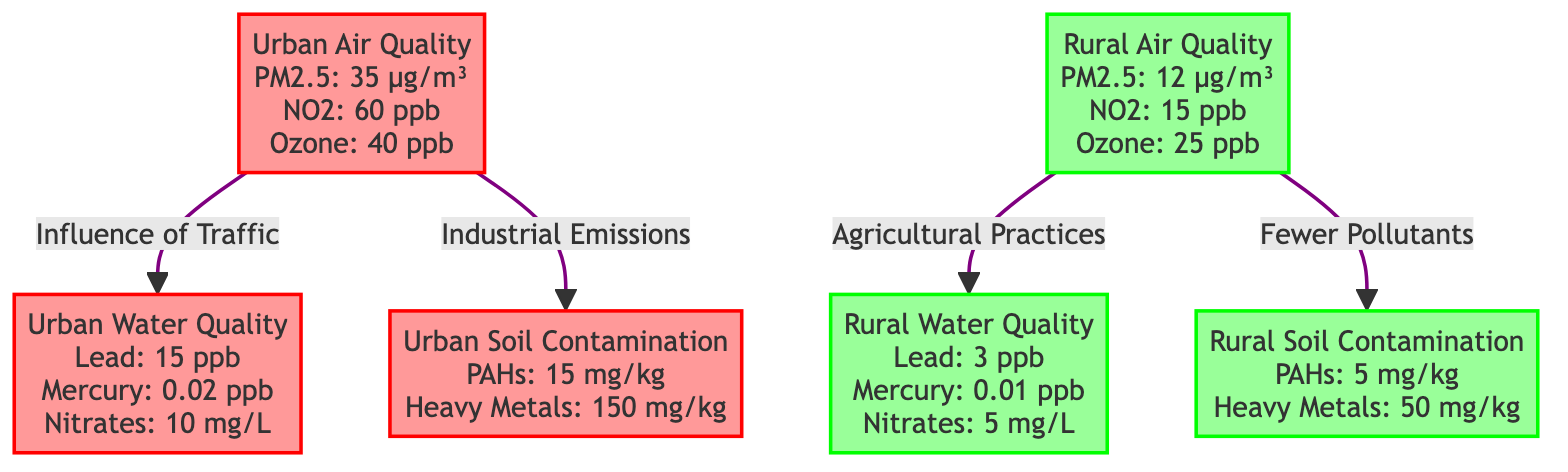What is the PM2.5 level in urban air quality? The PM2.5 level is written as 35 µg/m³ specifically under the urban air quality node in the diagram.
Answer: 35 µg/m³ What is the lead concentration in rural water quality? The lead concentration is indicated as 3 ppb within the rural water quality node in the diagram.
Answer: 3 ppb How many pollutants are monitored in urban soil contamination? The urban soil contamination node mentions two specific pollutants: PAHs and Heavy Metals, thus indicating that two pollutants are monitored.
Answer: 2 What is the relationship shown between urban air quality and urban water quality? The diagram indicates that urban air quality influences urban water quality, which is shown by a colored link connecting these two nodes.
Answer: Influence of Traffic What is the highest level of heavy metals found in urban soil contamination? The highest level of heavy metals is stated as 150 mg/kg in the urban soil contamination node of the diagram.
Answer: 150 mg/kg How much higher is the PM2.5 level in urban areas compared to rural areas? To find the difference, subtract the rural PM2.5 level of 12 µg/m³ from the urban PM2.5 level of 35 µg/m³, which results in a difference of 23 µg/m³.
Answer: 23 µg/m³ What is the concentration of nitrates in urban water quality? The concentration of nitrates is listed as 10 mg/L in the urban water quality node of the diagram.
Answer: 10 mg/L What does urban air quality influence in terms of soil quality? According to the diagram, urban air quality specifically influences soil contamination, linking these two aspects with a directed edge.
Answer: Soil Contamination How does rural air quality affect rural water quality? The diagram shows that rural air quality influences rural water quality via a connection, thus demonstrating the impact of one on the other through agricultural practices.
Answer: Agricultural Practices 